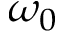Convert formula to latex. <formula><loc_0><loc_0><loc_500><loc_500>\omega _ { 0 }</formula> 